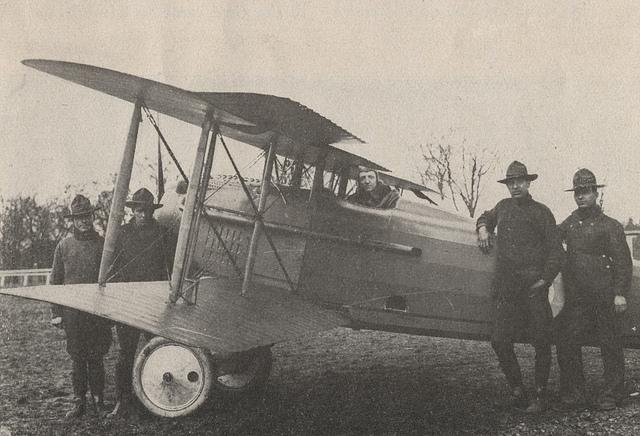How many men are in photo?
Concise answer only. 5. What color is the photo?
Give a very brief answer. Black and white. Is there an airplane?
Give a very brief answer. Yes. 